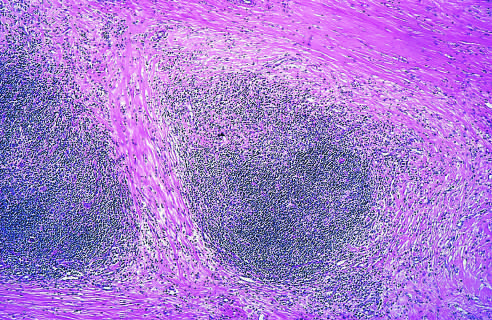does some long-lived resident tissue macrophages show well-defined bands of pink, acellular collagen that have subdivided the tumor cells into nodules?
Answer the question using a single word or phrase. No 